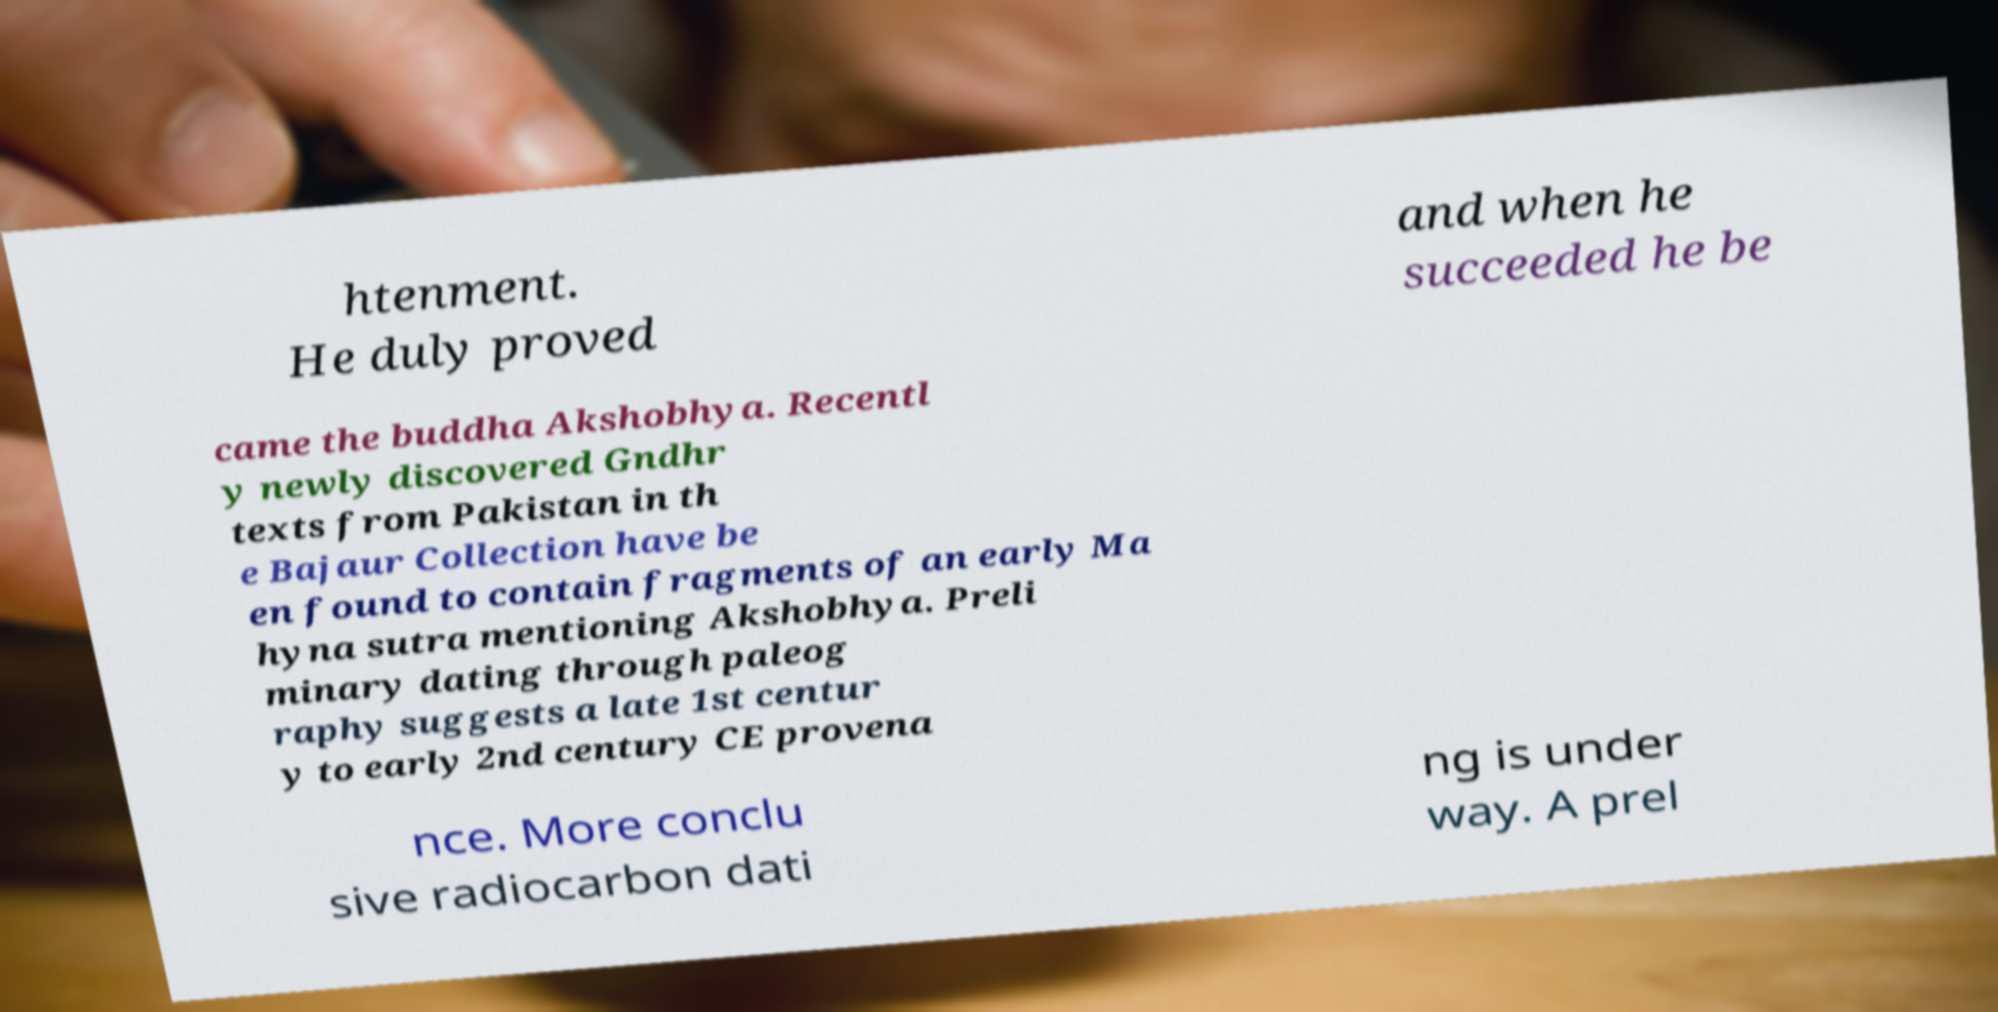Could you assist in decoding the text presented in this image and type it out clearly? htenment. He duly proved and when he succeeded he be came the buddha Akshobhya. Recentl y newly discovered Gndhr texts from Pakistan in th e Bajaur Collection have be en found to contain fragments of an early Ma hyna sutra mentioning Akshobhya. Preli minary dating through paleog raphy suggests a late 1st centur y to early 2nd century CE provena nce. More conclu sive radiocarbon dati ng is under way. A prel 